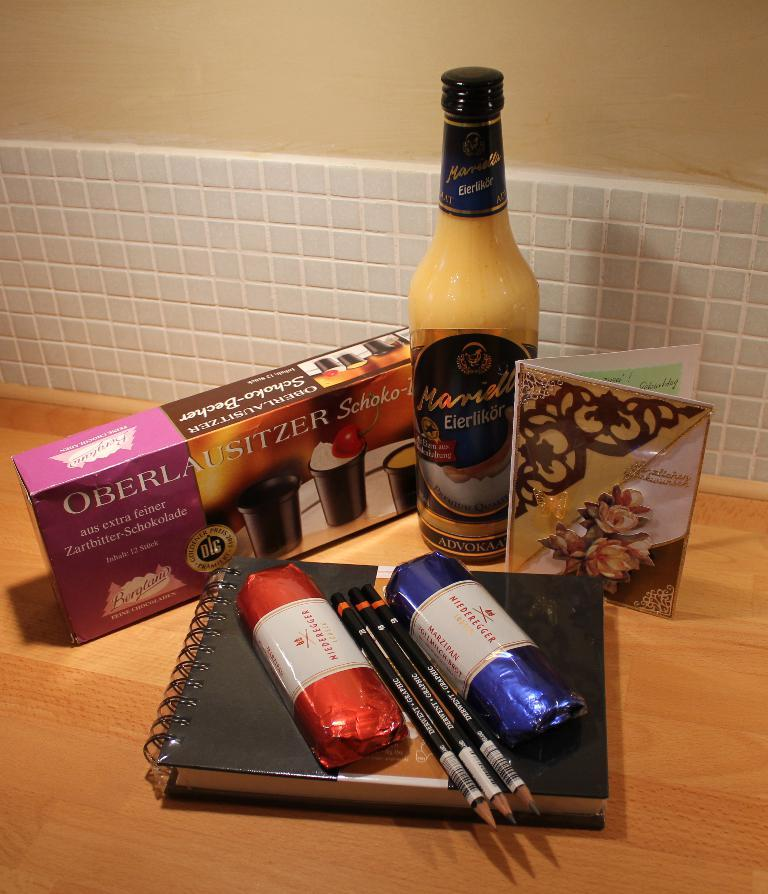<image>
Share a concise interpretation of the image provided. two packages of Niederegger marzipan set on a book laying in front of a bottle and a package of chocolate cups. 